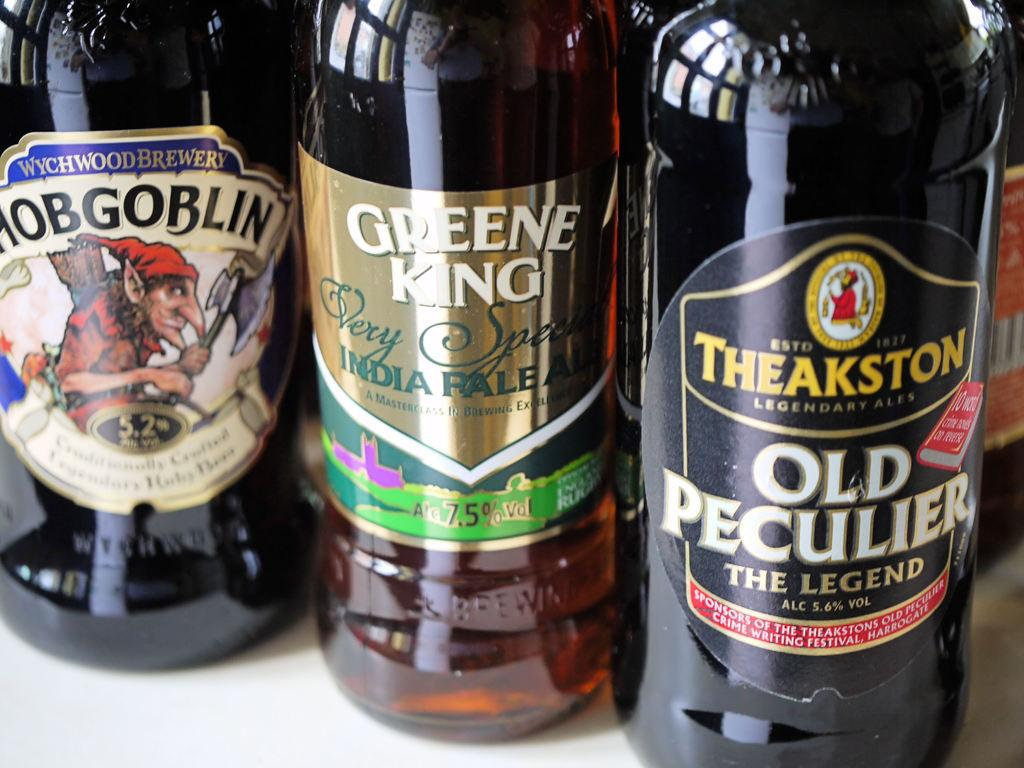<image>
Offer a succinct explanation of the picture presented. Three bottles of beer include brands like Hobgoblin and Old Peculier. 